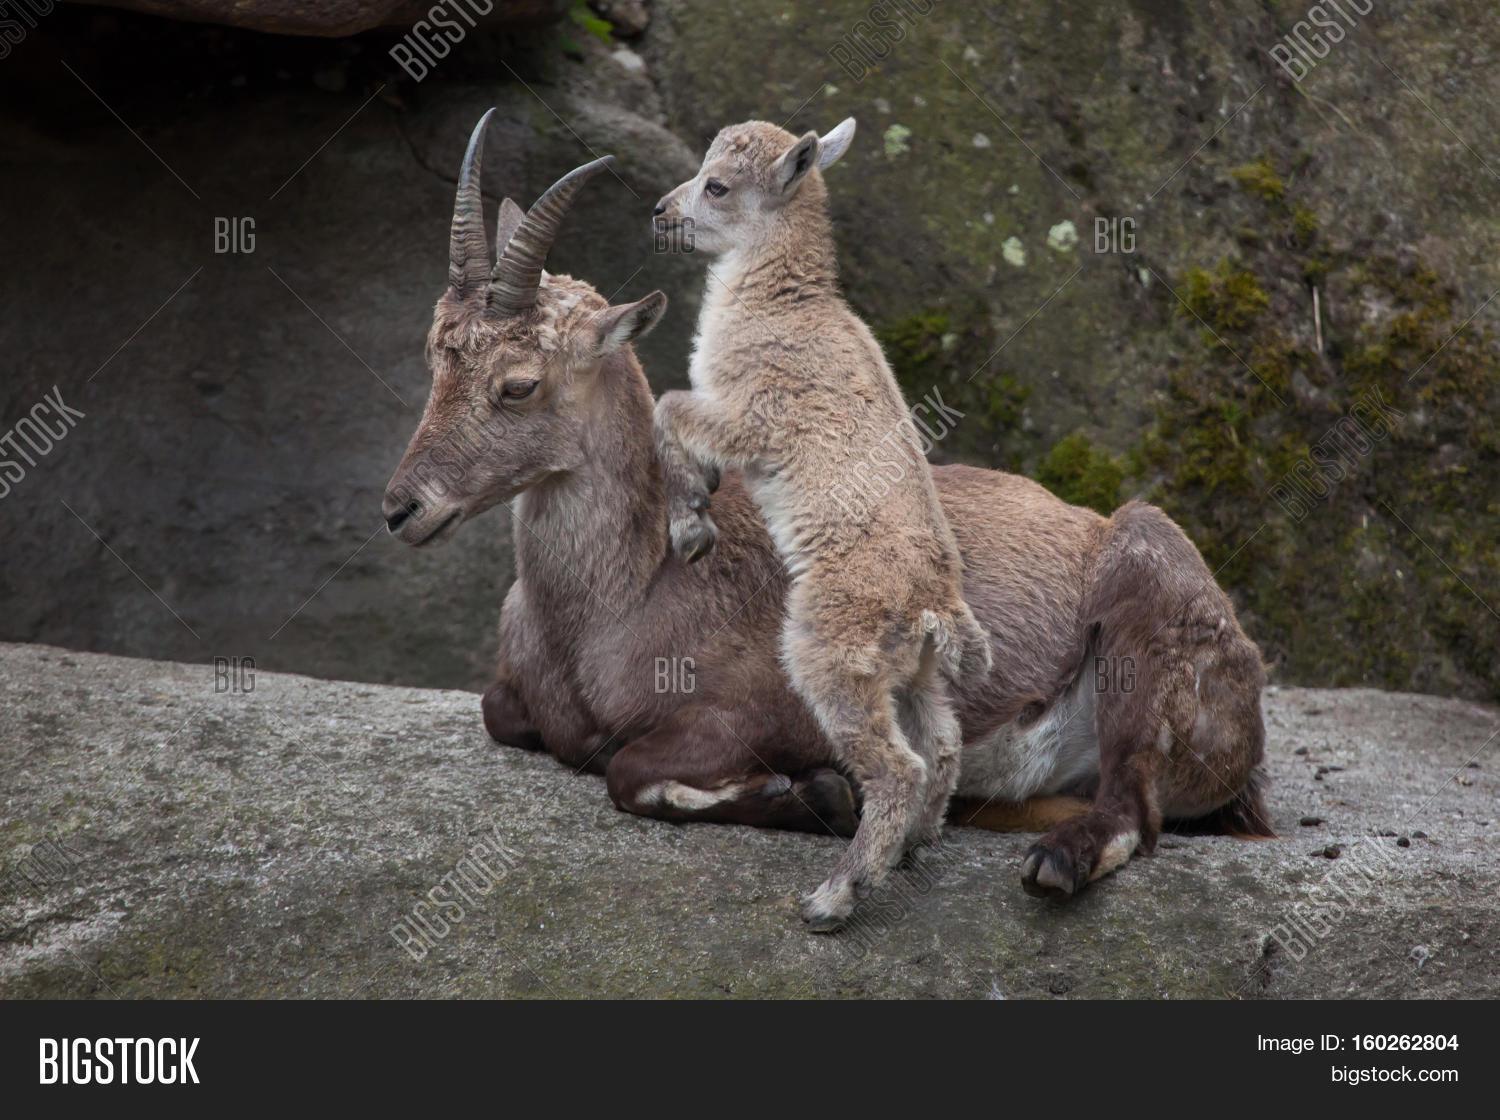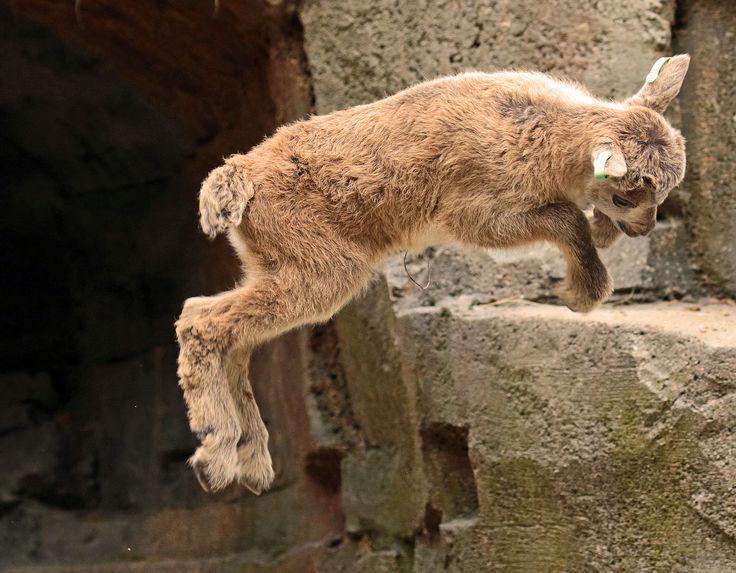The first image is the image on the left, the second image is the image on the right. Considering the images on both sides, is "There are two animals in the image on the left." valid? Answer yes or no. Yes. The first image is the image on the left, the second image is the image on the right. For the images displayed, is the sentence "The left image contains exactly two mountain goats." factually correct? Answer yes or no. Yes. 